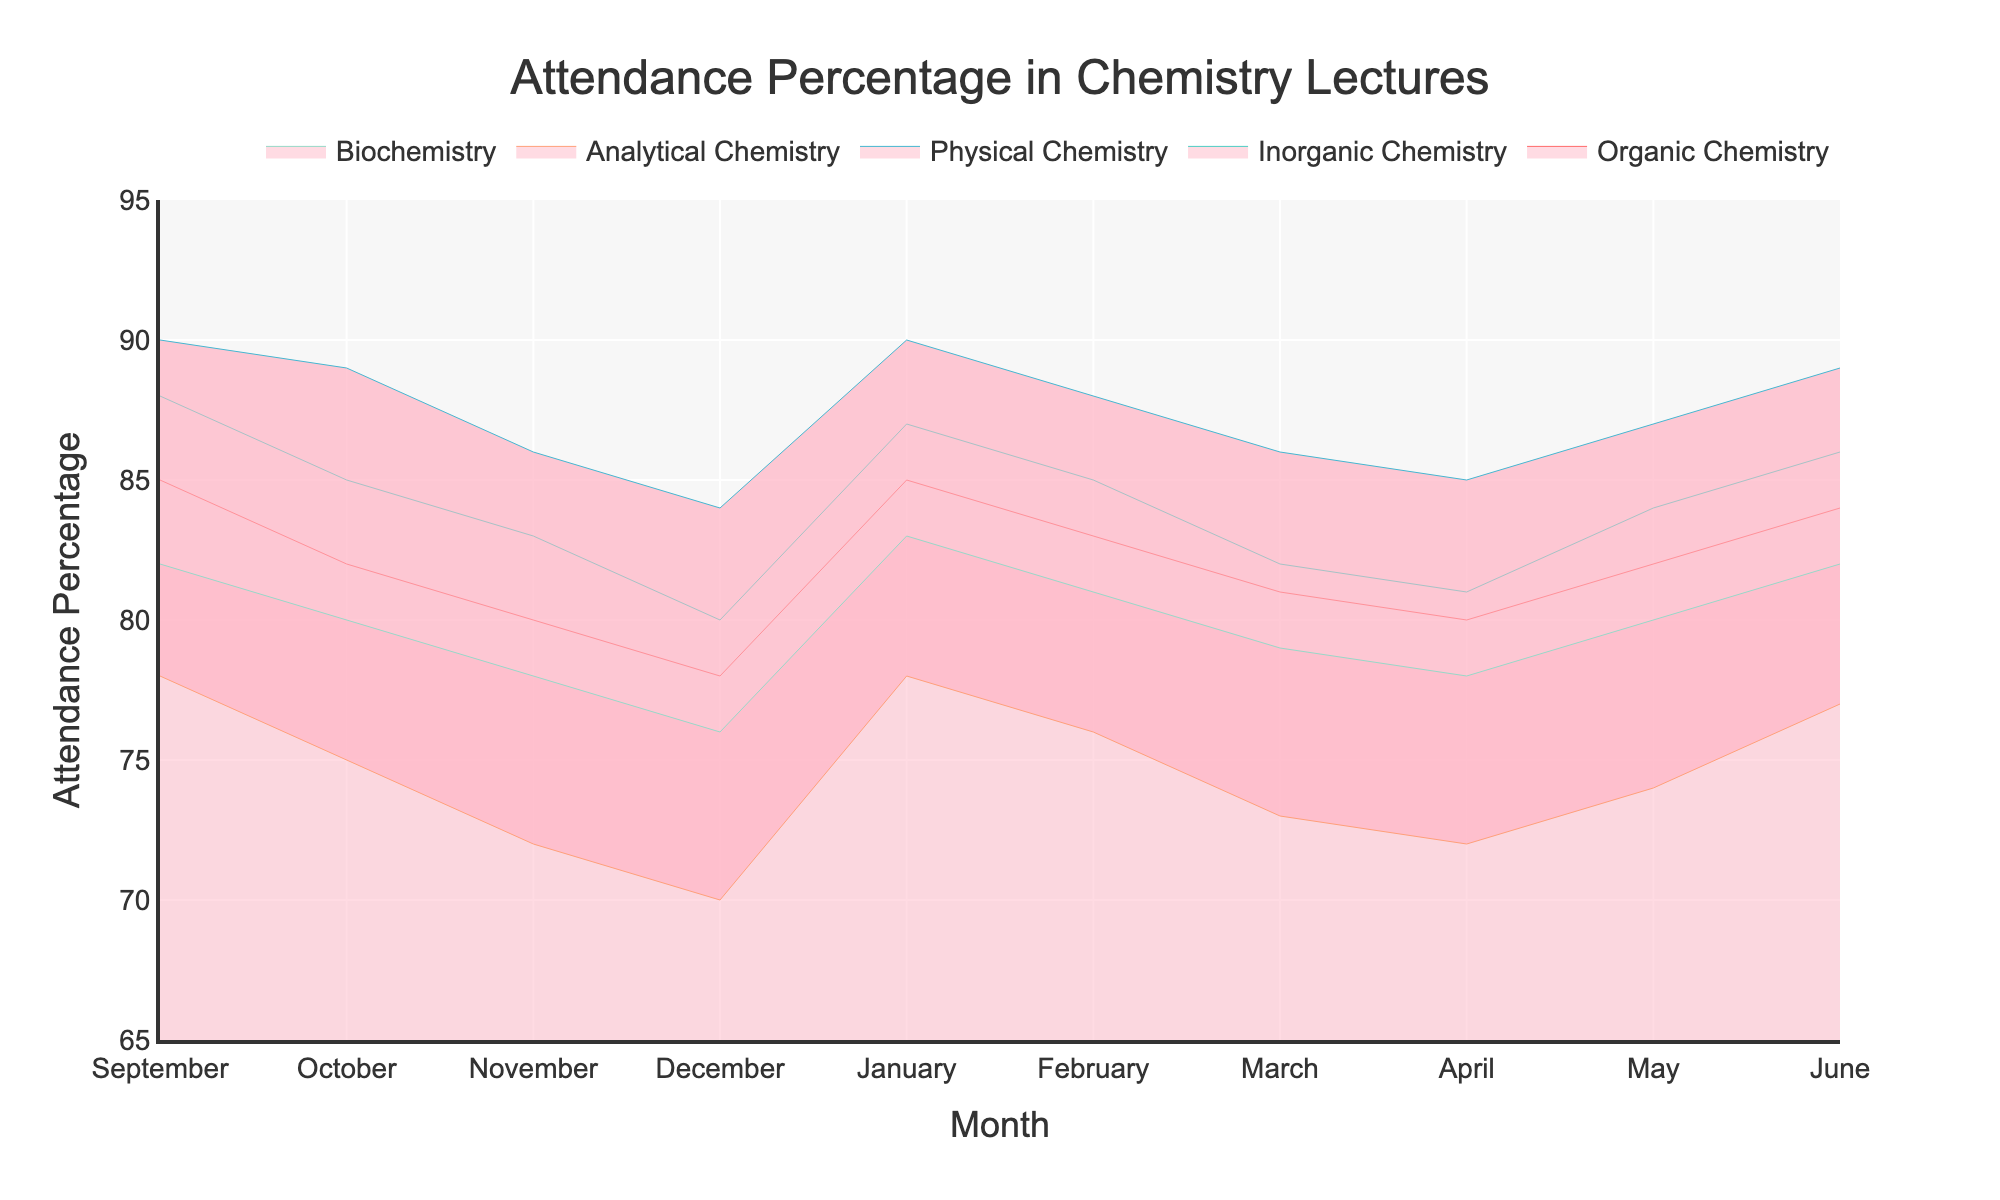what is the title of the plot? The title of the plot is located at the top and reads "Attendance Percentage in Chemistry Lectures".
Answer: Attendance Percentage in Chemistry Lectures what are the months displayed on the x-axis? The x-axis shows the months "September", "October", "November", "December", "January", "February", "March", "April", "May", and "June".
Answer: September, October, November, December, January, February, March, April, May, June which sub-discipline has the highest attendance in January? In January, by observing the plotted lines for each discipline, "Organic Chemistry" and "Physical Chemistry" both show attendance percentages of 90, which is the highest.
Answer: Organic Chemistry and Physical Chemistry how does the attendance in April for “Analytical Chemistry” compare to that in “May”? In April, the attendance for "Analytical Chemistry" is 72%, and in May, it increases to 74%. Therefore, the attendance in May is higher by 2%.
Answer: May is higher by 2% what is the average attendance percentage for “Biochemistry” across all months? To find the average, add the attendance percentages for "Biochemistry" (82+80+78+76+83+81+79+78+80+82) and divide by the number of months (10). Calculation: (82+80+78+76+83+81+79+78+80+82)/10 = 80.
Answer: 80 which month shows the lowest attendance percentage for "Inorganic Chemistry" and what is it? The lowest attendance percentage for "Inorganic Chemistry" is found by looking across all the months' values, which is 80% in December.
Answer: December, 80% what trend does "Physical Chemistry" attendance show from September to December? The attendance for "Physical Chemistry" from September (90%) to December (84%) shows a decreasing trend.
Answer: Decreasing trend how do the attendance percentages for "Organic Chemistry" in September and October compare? The attendance percentage for "Organic Chemistry" is 85% in September and 82% in October, showing a decrease of 3%.
Answer: Decrease by 3% which sub-discipline has the steadiest attendance trend throughout the year? By observing the lines of the plot, "Inorganic Chemistry" shows the least fluctuation in attendance percentages throughout the year, ranging from 80% to 88%.
Answer: Inorganic Chemistry how does the highest attendance for “Analytical Chemistry” compare to the lowest attendance for “Physical Chemistry” across the year? The highest attendance for "Analytical Chemistry" is 78% in January and September, while the lowest attendance for "Physical Chemistry" is 84% in December. Therefore, the lowest attendance for "Physical Chemistry" is still higher than the highest attendance for "Analytical Chemistry".
Answer: Higher 